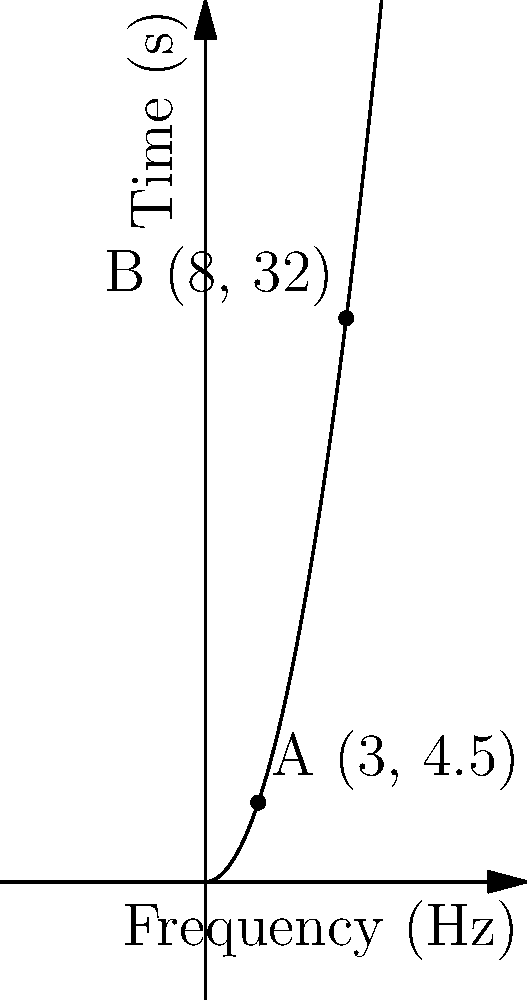On a spectrogram representing the evolution of a synthesizer sound, two significant frequency points are identified: A(3, 4.5) and B(8, 32), where the x-axis represents frequency in Hz and the y-axis represents time in seconds. Calculate the Euclidean distance between these two points to determine the magnitude of frequency change over time. To calculate the Euclidean distance between two points in a two-dimensional plane, we use the distance formula:

$$ d = \sqrt{(x_2 - x_1)^2 + (y_2 - y_1)^2} $$

Where $(x_1, y_1)$ are the coordinates of the first point and $(x_2, y_2)$ are the coordinates of the second point.

Given:
Point A: (3, 4.5)
Point B: (8, 32)

Step 1: Identify the coordinates
$x_1 = 3$, $y_1 = 4.5$
$x_2 = 8$, $y_2 = 32$

Step 2: Plug the values into the distance formula
$$ d = \sqrt{(8 - 3)^2 + (32 - 4.5)^2} $$

Step 3: Simplify the expressions inside the parentheses
$$ d = \sqrt{5^2 + 27.5^2} $$

Step 4: Calculate the squares
$$ d = \sqrt{25 + 756.25} $$

Step 5: Add the values under the square root
$$ d = \sqrt{781.25} $$

Step 6: Calculate the square root
$$ d \approx 27.95 $$

The Euclidean distance between points A and B on the spectrogram is approximately 27.95 units, representing the magnitude of frequency change over time.
Answer: 27.95 units 